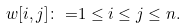<formula> <loc_0><loc_0><loc_500><loc_500>w [ i , j ] \colon = & 1 \leq i \leq j \leq n .</formula> 